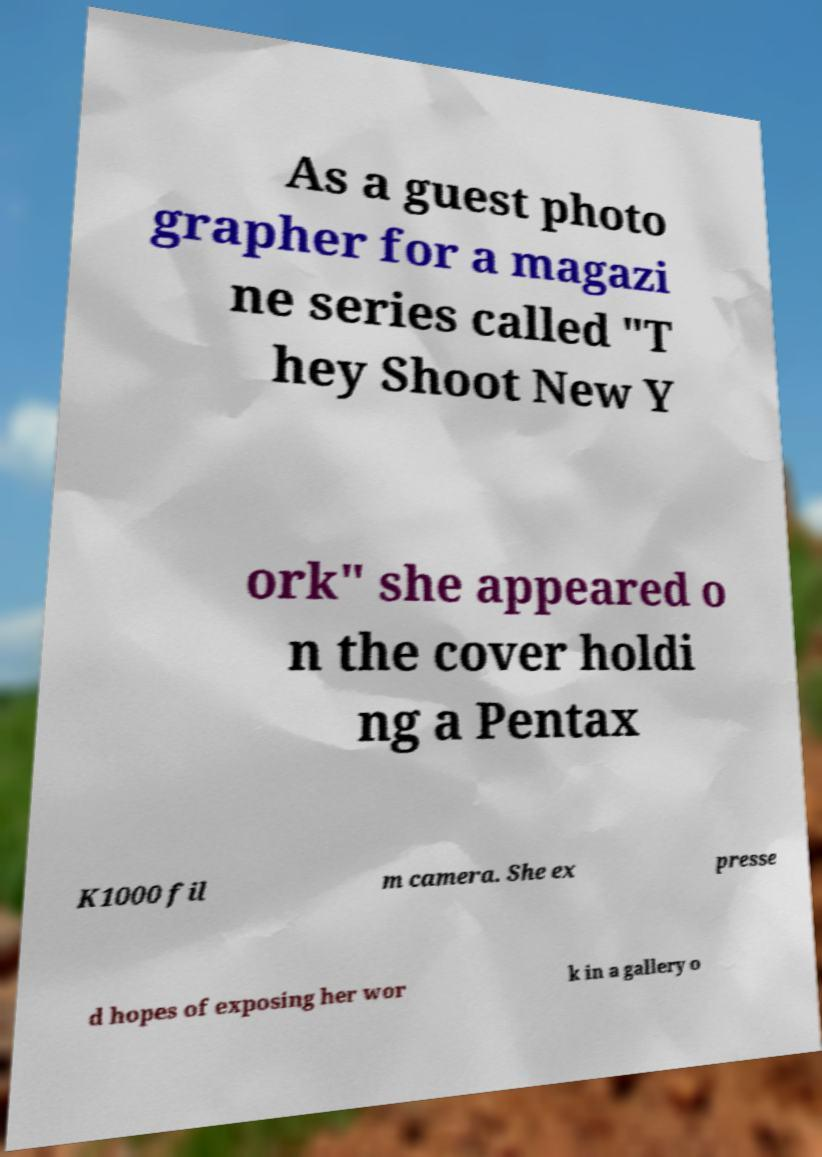Could you assist in decoding the text presented in this image and type it out clearly? As a guest photo grapher for a magazi ne series called "T hey Shoot New Y ork" she appeared o n the cover holdi ng a Pentax K1000 fil m camera. She ex presse d hopes of exposing her wor k in a gallery o 